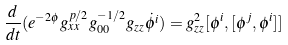Convert formula to latex. <formula><loc_0><loc_0><loc_500><loc_500>\frac { d } { d t } ( e ^ { - 2 \phi } g _ { x x } ^ { p / 2 } g _ { 0 0 } ^ { - 1 / 2 } g _ { z z } \dot { \phi ^ { i } } ) = g _ { z z } ^ { 2 } [ \phi ^ { i } , [ \phi ^ { j } , \phi ^ { i } ] ]</formula> 